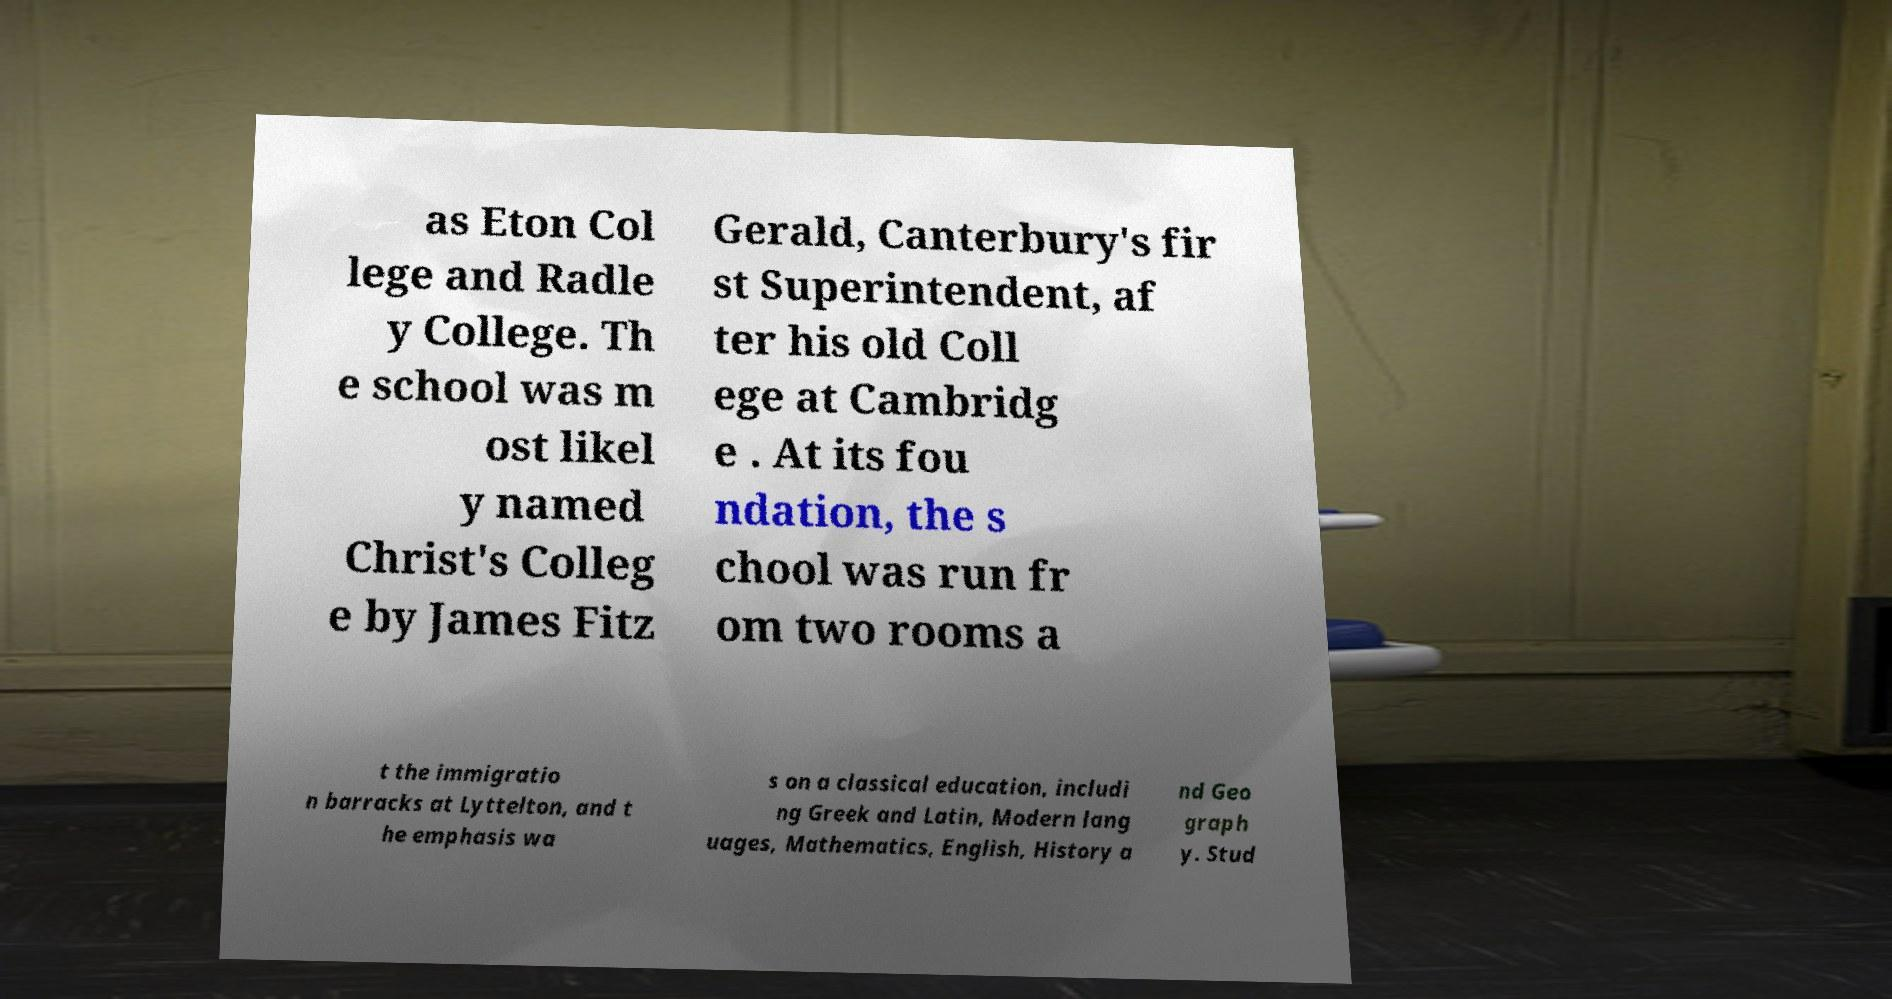Can you read and provide the text displayed in the image?This photo seems to have some interesting text. Can you extract and type it out for me? as Eton Col lege and Radle y College. Th e school was m ost likel y named Christ's Colleg e by James Fitz Gerald, Canterbury's fir st Superintendent, af ter his old Coll ege at Cambridg e . At its fou ndation, the s chool was run fr om two rooms a t the immigratio n barracks at Lyttelton, and t he emphasis wa s on a classical education, includi ng Greek and Latin, Modern lang uages, Mathematics, English, History a nd Geo graph y. Stud 